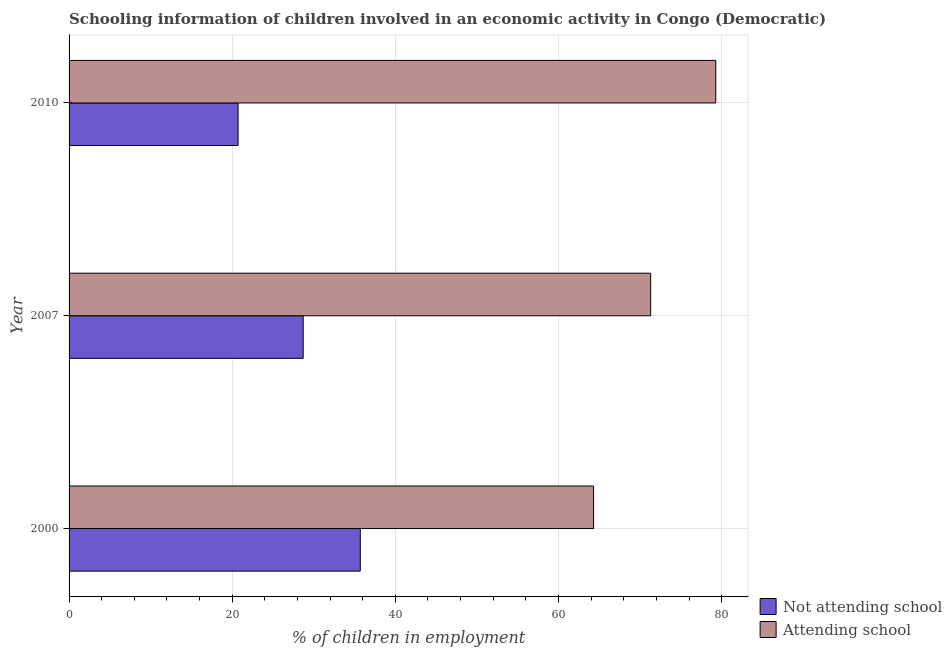How many different coloured bars are there?
Offer a terse response. 2. What is the label of the 2nd group of bars from the top?
Ensure brevity in your answer.  2007. What is the percentage of employed children who are not attending school in 2010?
Offer a terse response. 20.72. Across all years, what is the maximum percentage of employed children who are attending school?
Your response must be concise. 79.28. Across all years, what is the minimum percentage of employed children who are not attending school?
Give a very brief answer. 20.72. What is the total percentage of employed children who are attending school in the graph?
Ensure brevity in your answer.  214.88. What is the difference between the percentage of employed children who are attending school in 2000 and that in 2010?
Provide a succinct answer. -14.98. What is the difference between the percentage of employed children who are not attending school in 2010 and the percentage of employed children who are attending school in 2000?
Your answer should be very brief. -43.58. What is the average percentage of employed children who are not attending school per year?
Your response must be concise. 28.37. In the year 2007, what is the difference between the percentage of employed children who are not attending school and percentage of employed children who are attending school?
Offer a very short reply. -42.6. What is the ratio of the percentage of employed children who are not attending school in 2000 to that in 2007?
Give a very brief answer. 1.24. Is the percentage of employed children who are attending school in 2007 less than that in 2010?
Keep it short and to the point. Yes. What is the difference between the highest and the second highest percentage of employed children who are attending school?
Provide a succinct answer. 7.98. What is the difference between the highest and the lowest percentage of employed children who are not attending school?
Offer a very short reply. 14.98. In how many years, is the percentage of employed children who are attending school greater than the average percentage of employed children who are attending school taken over all years?
Keep it short and to the point. 1. What does the 1st bar from the top in 2010 represents?
Make the answer very short. Attending school. What does the 1st bar from the bottom in 2007 represents?
Your answer should be very brief. Not attending school. How many bars are there?
Keep it short and to the point. 6. How many years are there in the graph?
Your answer should be compact. 3. What is the difference between two consecutive major ticks on the X-axis?
Your response must be concise. 20. Are the values on the major ticks of X-axis written in scientific E-notation?
Your response must be concise. No. Does the graph contain grids?
Offer a terse response. Yes. Where does the legend appear in the graph?
Ensure brevity in your answer.  Bottom right. How many legend labels are there?
Your response must be concise. 2. What is the title of the graph?
Keep it short and to the point. Schooling information of children involved in an economic activity in Congo (Democratic). What is the label or title of the X-axis?
Your response must be concise. % of children in employment. What is the % of children in employment of Not attending school in 2000?
Keep it short and to the point. 35.7. What is the % of children in employment in Attending school in 2000?
Offer a very short reply. 64.3. What is the % of children in employment in Not attending school in 2007?
Keep it short and to the point. 28.7. What is the % of children in employment in Attending school in 2007?
Offer a terse response. 71.3. What is the % of children in employment in Not attending school in 2010?
Make the answer very short. 20.72. What is the % of children in employment in Attending school in 2010?
Offer a terse response. 79.28. Across all years, what is the maximum % of children in employment in Not attending school?
Ensure brevity in your answer.  35.7. Across all years, what is the maximum % of children in employment of Attending school?
Provide a short and direct response. 79.28. Across all years, what is the minimum % of children in employment of Not attending school?
Offer a very short reply. 20.72. Across all years, what is the minimum % of children in employment in Attending school?
Provide a short and direct response. 64.3. What is the total % of children in employment of Not attending school in the graph?
Your answer should be very brief. 85.12. What is the total % of children in employment in Attending school in the graph?
Your answer should be compact. 214.88. What is the difference between the % of children in employment in Attending school in 2000 and that in 2007?
Your response must be concise. -7. What is the difference between the % of children in employment of Not attending school in 2000 and that in 2010?
Provide a succinct answer. 14.98. What is the difference between the % of children in employment of Attending school in 2000 and that in 2010?
Make the answer very short. -14.98. What is the difference between the % of children in employment of Not attending school in 2007 and that in 2010?
Offer a very short reply. 7.98. What is the difference between the % of children in employment in Attending school in 2007 and that in 2010?
Provide a short and direct response. -7.98. What is the difference between the % of children in employment in Not attending school in 2000 and the % of children in employment in Attending school in 2007?
Your answer should be compact. -35.6. What is the difference between the % of children in employment of Not attending school in 2000 and the % of children in employment of Attending school in 2010?
Your answer should be compact. -43.58. What is the difference between the % of children in employment of Not attending school in 2007 and the % of children in employment of Attending school in 2010?
Give a very brief answer. -50.58. What is the average % of children in employment of Not attending school per year?
Your answer should be very brief. 28.37. What is the average % of children in employment in Attending school per year?
Your response must be concise. 71.63. In the year 2000, what is the difference between the % of children in employment of Not attending school and % of children in employment of Attending school?
Ensure brevity in your answer.  -28.6. In the year 2007, what is the difference between the % of children in employment in Not attending school and % of children in employment in Attending school?
Make the answer very short. -42.6. In the year 2010, what is the difference between the % of children in employment in Not attending school and % of children in employment in Attending school?
Your answer should be compact. -58.56. What is the ratio of the % of children in employment of Not attending school in 2000 to that in 2007?
Keep it short and to the point. 1.24. What is the ratio of the % of children in employment of Attending school in 2000 to that in 2007?
Your answer should be compact. 0.9. What is the ratio of the % of children in employment in Not attending school in 2000 to that in 2010?
Give a very brief answer. 1.72. What is the ratio of the % of children in employment in Attending school in 2000 to that in 2010?
Your response must be concise. 0.81. What is the ratio of the % of children in employment in Not attending school in 2007 to that in 2010?
Offer a very short reply. 1.39. What is the ratio of the % of children in employment in Attending school in 2007 to that in 2010?
Ensure brevity in your answer.  0.9. What is the difference between the highest and the second highest % of children in employment in Attending school?
Your answer should be very brief. 7.98. What is the difference between the highest and the lowest % of children in employment in Not attending school?
Provide a short and direct response. 14.98. What is the difference between the highest and the lowest % of children in employment of Attending school?
Your answer should be very brief. 14.98. 